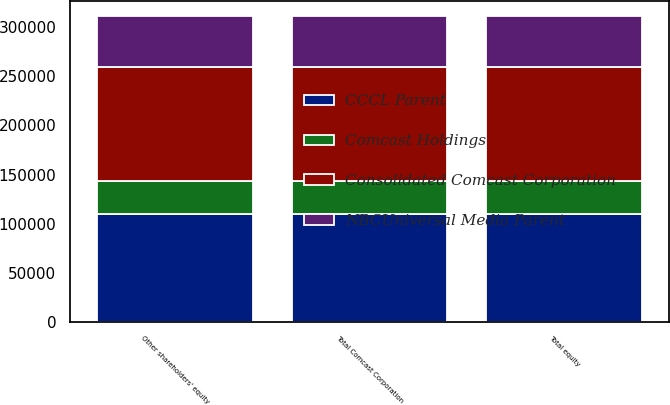Convert chart. <chart><loc_0><loc_0><loc_500><loc_500><stacked_bar_chart><ecel><fcel>Other shareholders' equity<fcel>Total Comcast Corporation<fcel>Total equity<nl><fcel>NBCUniversal Media Parent<fcel>52240<fcel>52269<fcel>52269<nl><fcel>CCCL Parent<fcel>110299<fcel>110299<fcel>110299<nl><fcel>Consolidated Comcast Corporation<fcel>116414<fcel>116414<fcel>116414<nl><fcel>Comcast Holdings<fcel>32622<fcel>32622<fcel>32622<nl></chart> 